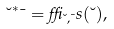Convert formula to latex. <formula><loc_0><loc_0><loc_500><loc_500>\lambda ^ { * } \mu = \delta _ { \lambda , \mu } s ( \lambda ) ,</formula> 